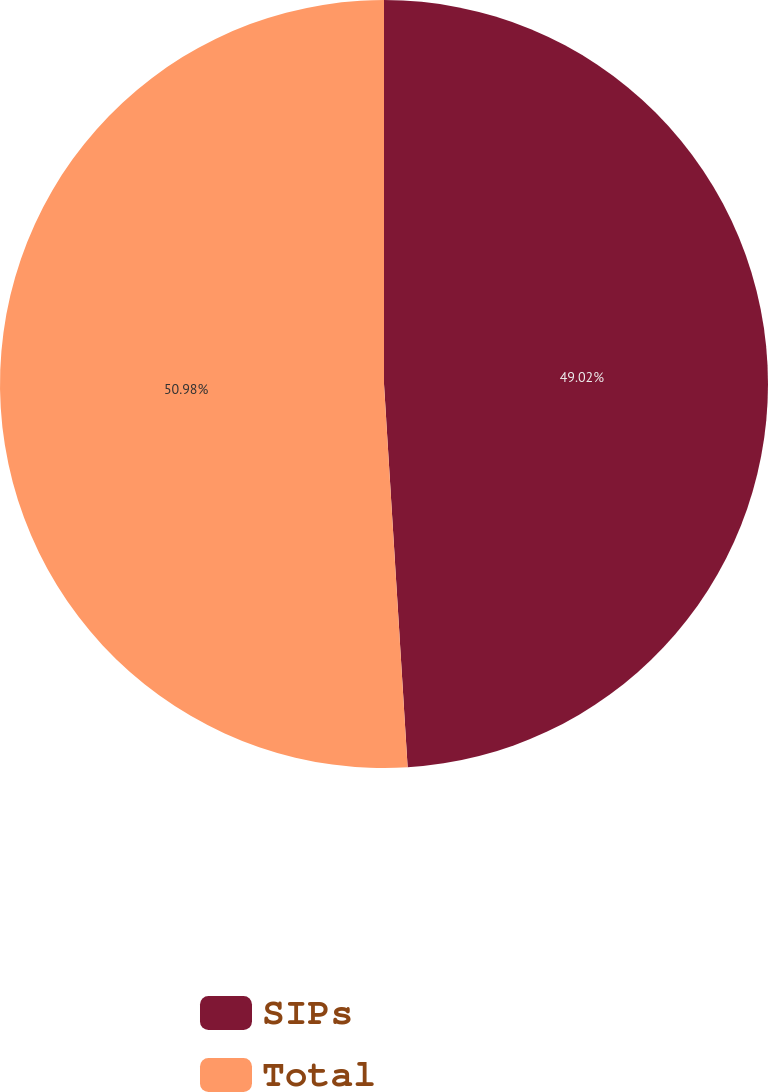Convert chart. <chart><loc_0><loc_0><loc_500><loc_500><pie_chart><fcel>SIPs<fcel>Total<nl><fcel>49.02%<fcel>50.98%<nl></chart> 